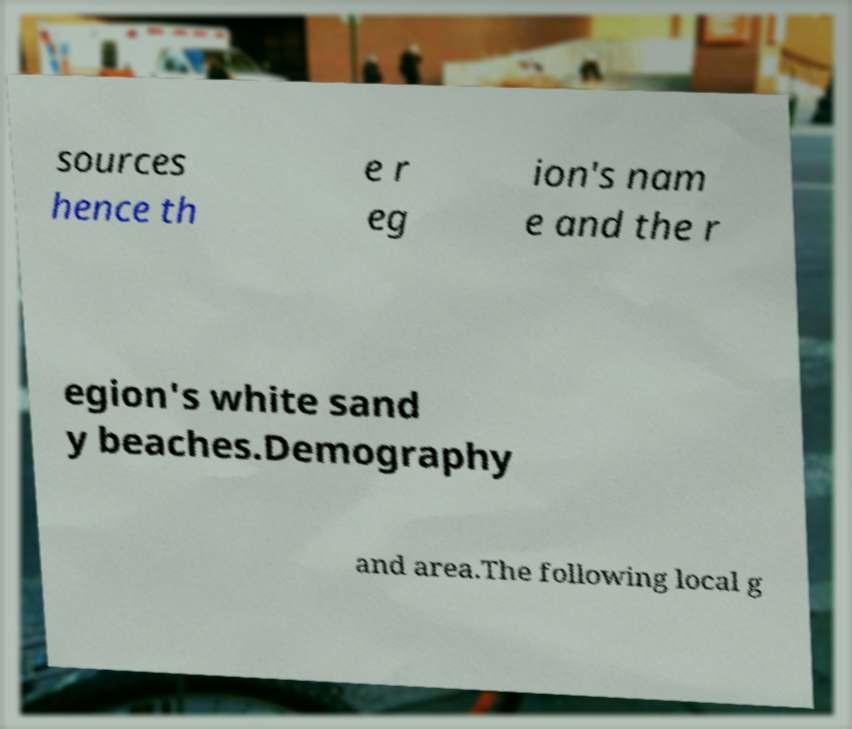Please identify and transcribe the text found in this image. sources hence th e r eg ion's nam e and the r egion's white sand y beaches.Demography and area.The following local g 